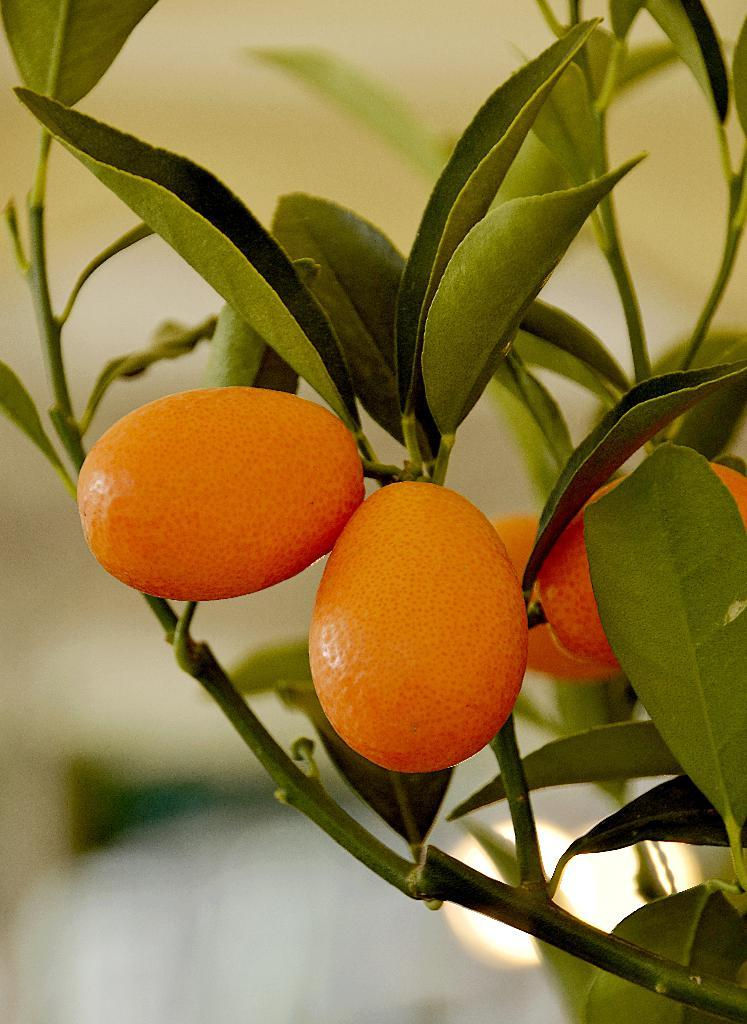What is present in the picture? There is a plant in the picture. What can be observed on the plant? The plant has orange color things on it. How would you describe the background of the image? The background of the image is blurred. Can you see any quills on the plant in the image? There are no quills visible on the plant in the image. How many eyes can be seen on the plant in the image? Plants do not have eyes, so there are no eyes visible on the plant in the image. 